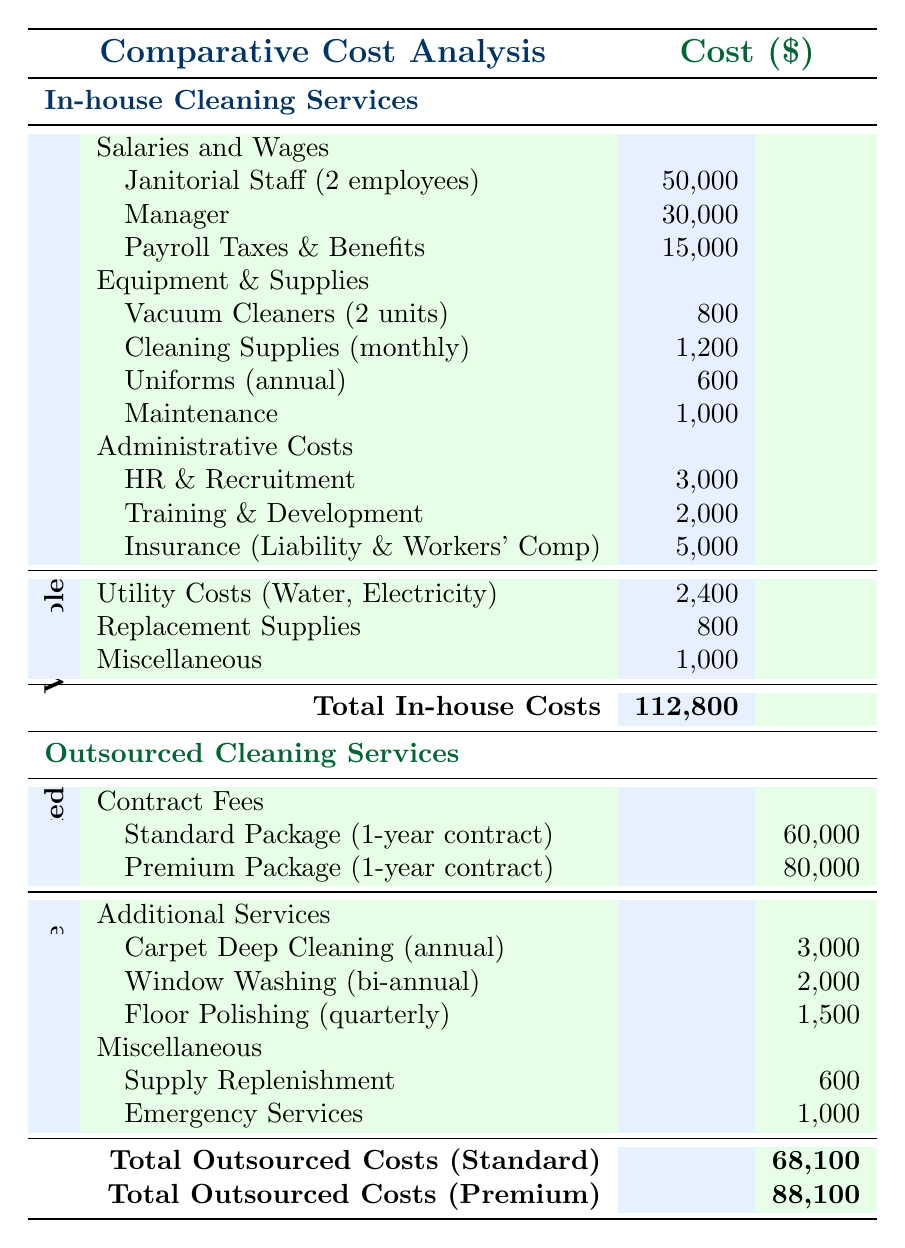What is the total fixed cost for in-house cleaning services? The total fixed cost for in-house cleaning services is the sum of salaries and wages, equipment and supplies, and administrative costs. Adding the values gives: 50,000 + 30,000 + 15,000 + 800 + 1,200 + 600 + 1,000 + 3,000 + 2,000 + 5,000 = 109,600.
Answer: 109,600 What is the total cost of the standard outsourced cleaning package? The total cost of the standard outsourced cleaning package includes the contract fee and any additional services listed. The contract fee is 60,000, and adding the additional services gives: 60,000 + 3,000 + 2,000 + 1,500 + 600 + 1,000 = 68,100.
Answer: 68,100 Is the total variable cost for in-house cleaning services greater than the total variable cost for outsourced cleaning services? The total variable cost for in-house cleaning services is the sum of utility costs, replacement supplies, and miscellaneous costs, which equals 2,400 + 800 + 1,000 = 4,200. For outsourced services, the total variable costs add up to: 3,000 + 2,000 + 1,500 + 600 + 1,000 = 8,100. Since 4,200 is less than 8,100, the answer is no.
Answer: No What are the total costs for the in-house cleaning services compared to the premium outsourced cleaning services? The total costs for in-house cleaning services is 112,800. For premium outsourced cleaning services, the total is 88,100. Comparing these two amounts: 112,800 is greater than 88,100. Thus, in-house cleaning services are costlier.
Answer: In-house is costlier How much more do in-house cleaning services cost compared to the standard outsourced package? The total cost for in-house cleaning services is 112,800 and for the standard outsourced package, it's 68,100. The difference is calculated as 112,800 - 68,100 = 44,700, indicating in-house services cost 44,700 more.
Answer: 44,700 